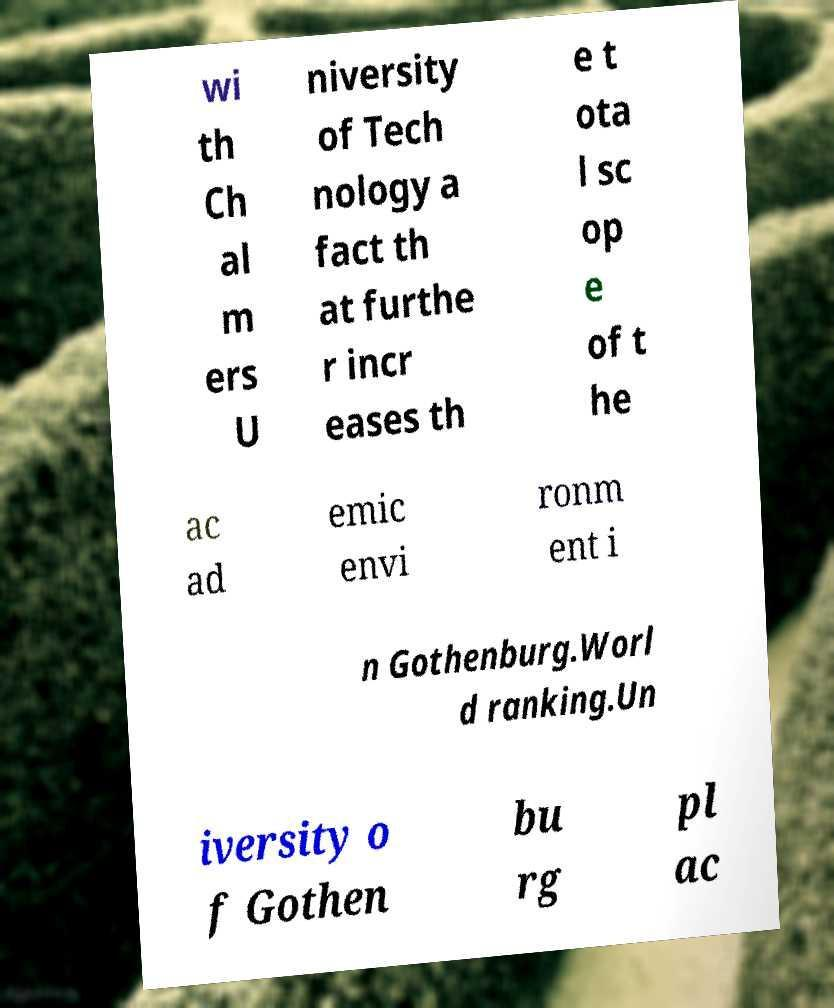What messages or text are displayed in this image? I need them in a readable, typed format. wi th Ch al m ers U niversity of Tech nology a fact th at furthe r incr eases th e t ota l sc op e of t he ac ad emic envi ronm ent i n Gothenburg.Worl d ranking.Un iversity o f Gothen bu rg pl ac 